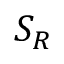Convert formula to latex. <formula><loc_0><loc_0><loc_500><loc_500>S _ { R }</formula> 